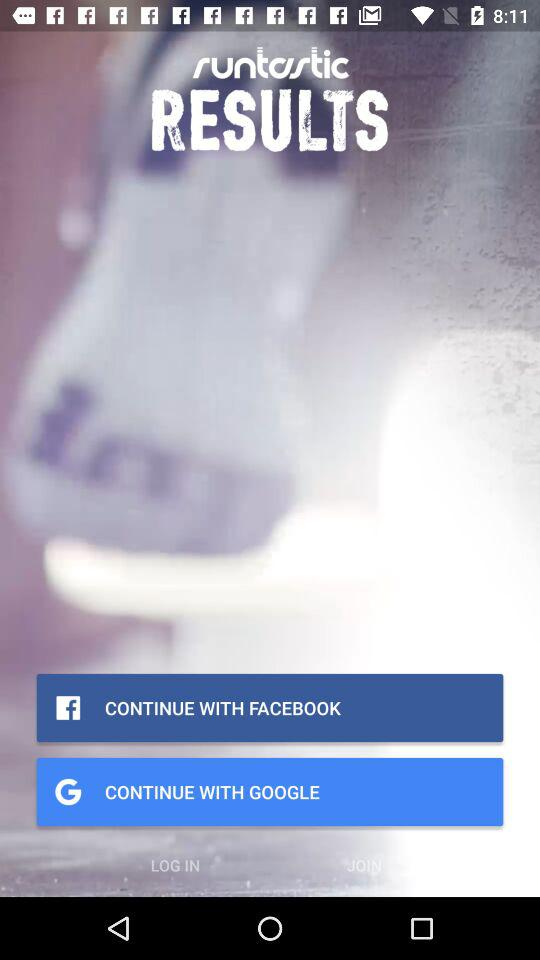How many calories do the exercises burn?
When the provided information is insufficient, respond with <no answer>. <no answer> 